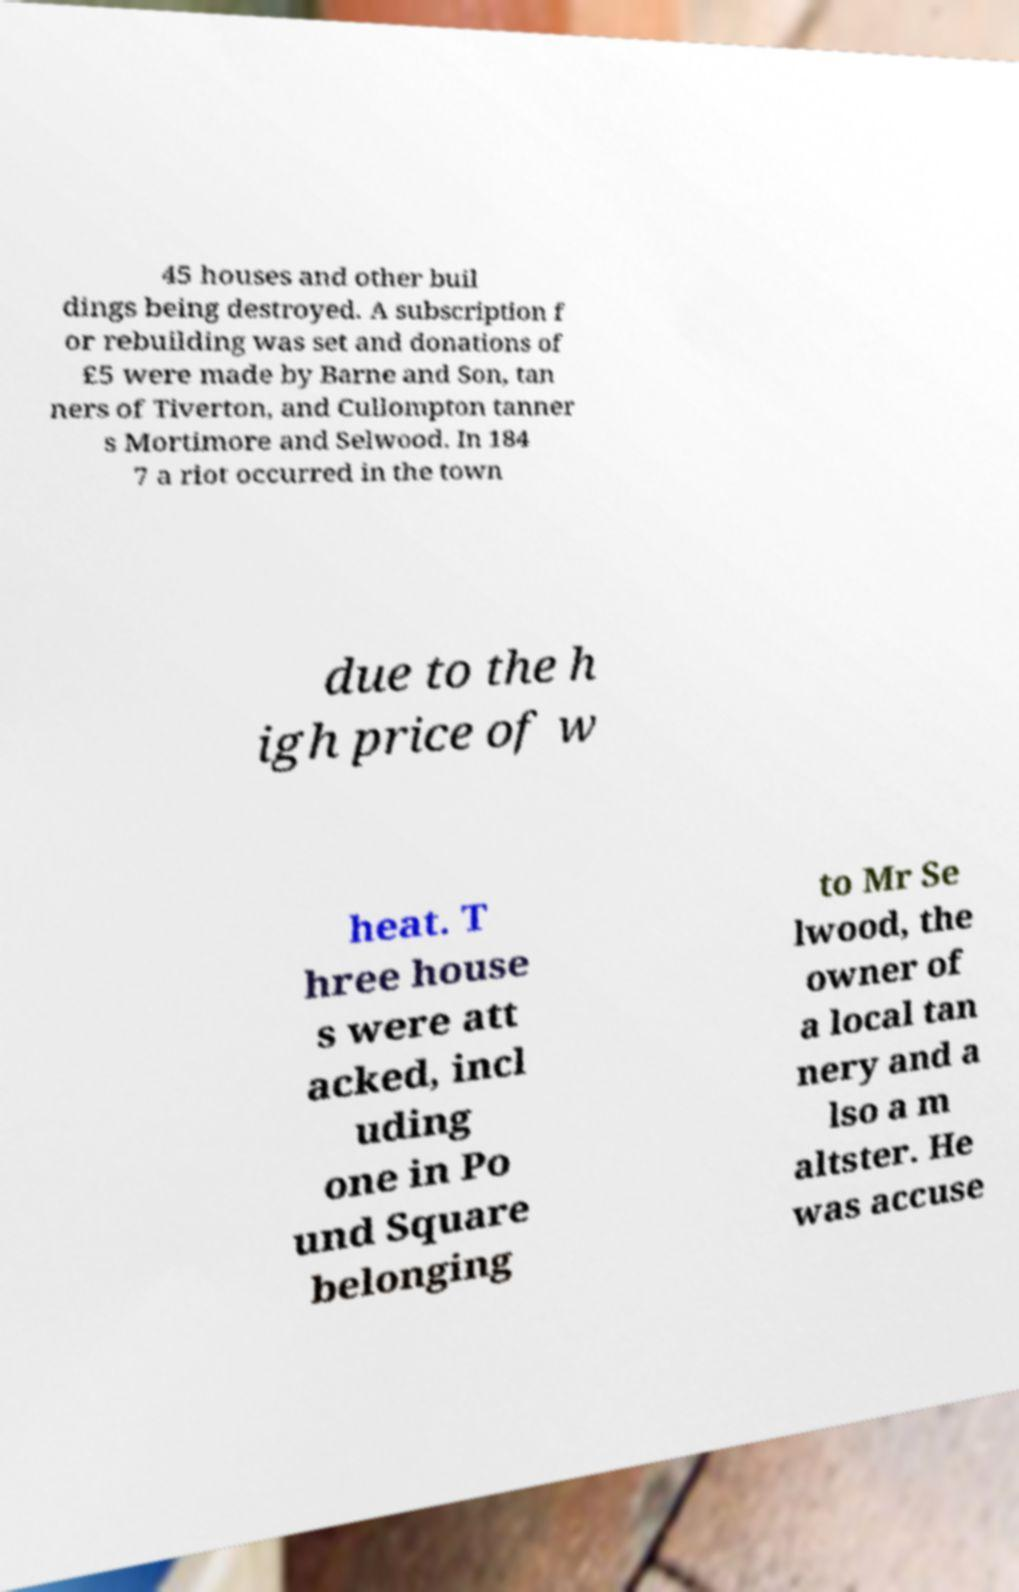I need the written content from this picture converted into text. Can you do that? 45 houses and other buil dings being destroyed. A subscription f or rebuilding was set and donations of £5 were made by Barne and Son, tan ners of Tiverton, and Cullompton tanner s Mortimore and Selwood. In 184 7 a riot occurred in the town due to the h igh price of w heat. T hree house s were att acked, incl uding one in Po und Square belonging to Mr Se lwood, the owner of a local tan nery and a lso a m altster. He was accuse 